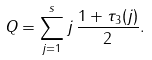<formula> <loc_0><loc_0><loc_500><loc_500>Q = \sum _ { j = 1 } ^ { s } j \, \frac { 1 + \tau _ { 3 } ( j ) } { 2 } .</formula> 